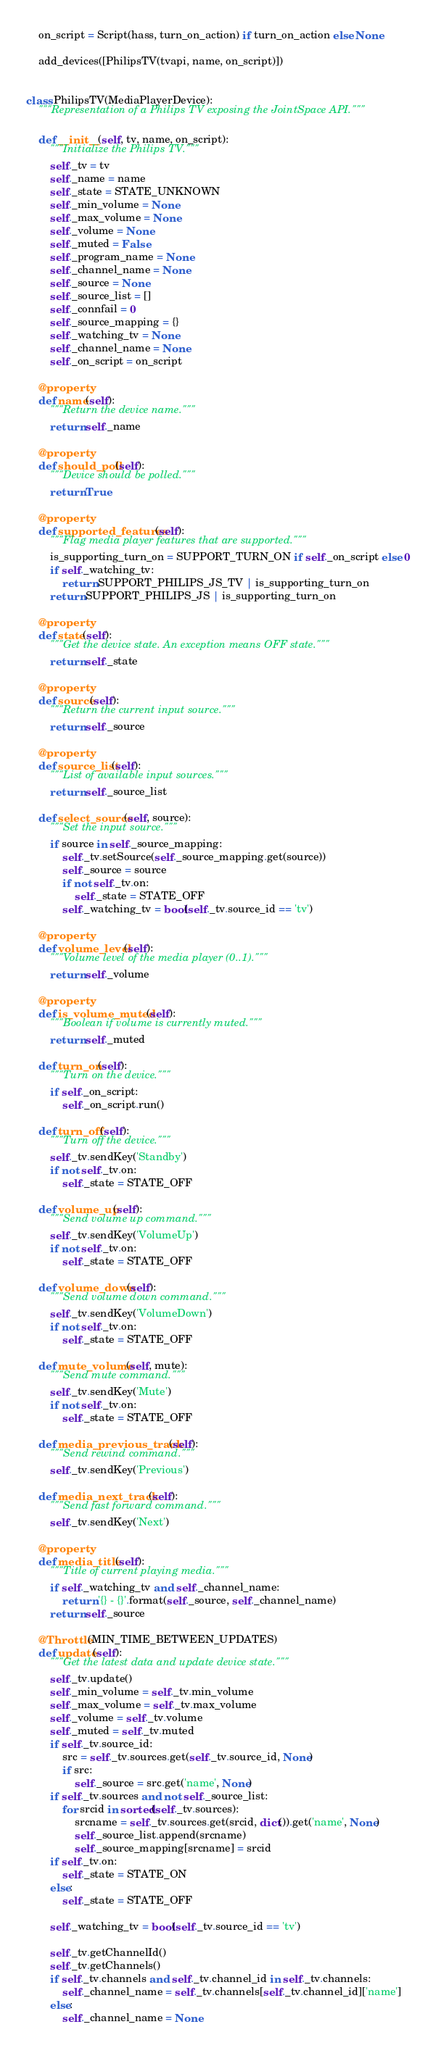Convert code to text. <code><loc_0><loc_0><loc_500><loc_500><_Python_>    on_script = Script(hass, turn_on_action) if turn_on_action else None

    add_devices([PhilipsTV(tvapi, name, on_script)])


class PhilipsTV(MediaPlayerDevice):
    """Representation of a Philips TV exposing the JointSpace API."""

    def __init__(self, tv, name, on_script):
        """Initialize the Philips TV."""
        self._tv = tv
        self._name = name
        self._state = STATE_UNKNOWN
        self._min_volume = None
        self._max_volume = None
        self._volume = None
        self._muted = False
        self._program_name = None
        self._channel_name = None
        self._source = None
        self._source_list = []
        self._connfail = 0
        self._source_mapping = {}
        self._watching_tv = None
        self._channel_name = None
        self._on_script = on_script

    @property
    def name(self):
        """Return the device name."""
        return self._name

    @property
    def should_poll(self):
        """Device should be polled."""
        return True

    @property
    def supported_features(self):
        """Flag media player features that are supported."""
        is_supporting_turn_on = SUPPORT_TURN_ON if self._on_script else 0
        if self._watching_tv:
            return SUPPORT_PHILIPS_JS_TV | is_supporting_turn_on
        return SUPPORT_PHILIPS_JS | is_supporting_turn_on

    @property
    def state(self):
        """Get the device state. An exception means OFF state."""
        return self._state

    @property
    def source(self):
        """Return the current input source."""
        return self._source

    @property
    def source_list(self):
        """List of available input sources."""
        return self._source_list

    def select_source(self, source):
        """Set the input source."""
        if source in self._source_mapping:
            self._tv.setSource(self._source_mapping.get(source))
            self._source = source
            if not self._tv.on:
                self._state = STATE_OFF
            self._watching_tv = bool(self._tv.source_id == 'tv')

    @property
    def volume_level(self):
        """Volume level of the media player (0..1)."""
        return self._volume

    @property
    def is_volume_muted(self):
        """Boolean if volume is currently muted."""
        return self._muted

    def turn_on(self):
        """Turn on the device."""
        if self._on_script:
            self._on_script.run()

    def turn_off(self):
        """Turn off the device."""
        self._tv.sendKey('Standby')
        if not self._tv.on:
            self._state = STATE_OFF

    def volume_up(self):
        """Send volume up command."""
        self._tv.sendKey('VolumeUp')
        if not self._tv.on:
            self._state = STATE_OFF

    def volume_down(self):
        """Send volume down command."""
        self._tv.sendKey('VolumeDown')
        if not self._tv.on:
            self._state = STATE_OFF

    def mute_volume(self, mute):
        """Send mute command."""
        self._tv.sendKey('Mute')
        if not self._tv.on:
            self._state = STATE_OFF

    def media_previous_track(self):
        """Send rewind command."""
        self._tv.sendKey('Previous')

    def media_next_track(self):
        """Send fast forward command."""
        self._tv.sendKey('Next')

    @property
    def media_title(self):
        """Title of current playing media."""
        if self._watching_tv and self._channel_name:
            return '{} - {}'.format(self._source, self._channel_name)
        return self._source

    @Throttle(MIN_TIME_BETWEEN_UPDATES)
    def update(self):
        """Get the latest data and update device state."""
        self._tv.update()
        self._min_volume = self._tv.min_volume
        self._max_volume = self._tv.max_volume
        self._volume = self._tv.volume
        self._muted = self._tv.muted
        if self._tv.source_id:
            src = self._tv.sources.get(self._tv.source_id, None)
            if src:
                self._source = src.get('name', None)
        if self._tv.sources and not self._source_list:
            for srcid in sorted(self._tv.sources):
                srcname = self._tv.sources.get(srcid, dict()).get('name', None)
                self._source_list.append(srcname)
                self._source_mapping[srcname] = srcid
        if self._tv.on:
            self._state = STATE_ON
        else:
            self._state = STATE_OFF

        self._watching_tv = bool(self._tv.source_id == 'tv')

        self._tv.getChannelId()
        self._tv.getChannels()
        if self._tv.channels and self._tv.channel_id in self._tv.channels:
            self._channel_name = self._tv.channels[self._tv.channel_id]['name']
        else:
            self._channel_name = None
</code> 